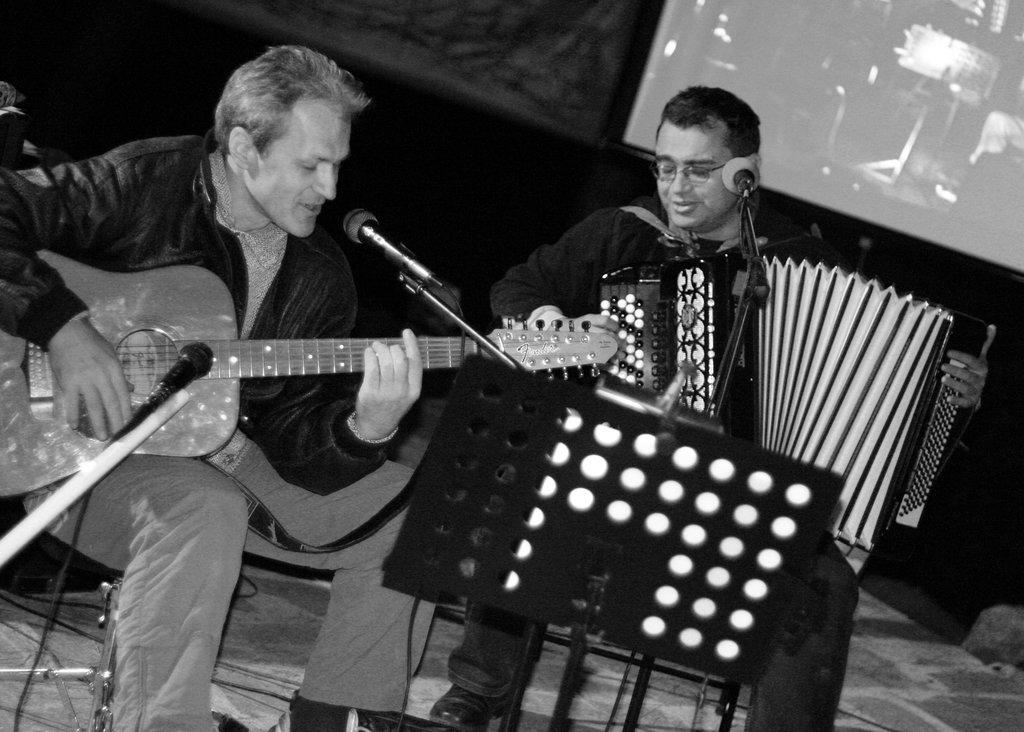How many people are in the image? There are two people in the image. What are the two people doing in the image? The two people are sitting on a chair and playing musical instruments. What type of kite is being played by the two people in the image? There is no kite present in the image; the two people are playing musical instruments. How do the two people grip their instruments in the image? The image does not show the specific way the two people grip their instruments, but they are playing them. 